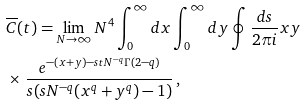Convert formula to latex. <formula><loc_0><loc_0><loc_500><loc_500>& \overline { C } ( t ) = \lim _ { N \rightarrow \infty } N ^ { 4 } \int _ { 0 } ^ { \infty } d x \int _ { 0 } ^ { \infty } d y \oint \frac { d s } { 2 \pi i } x y \\ & \times \, \frac { e ^ { - ( x + y ) - s t N ^ { - q } \Gamma ( 2 - q ) } } { s ( s N ^ { - q } ( x ^ { q } + y ^ { q } ) - 1 ) } \, ,</formula> 